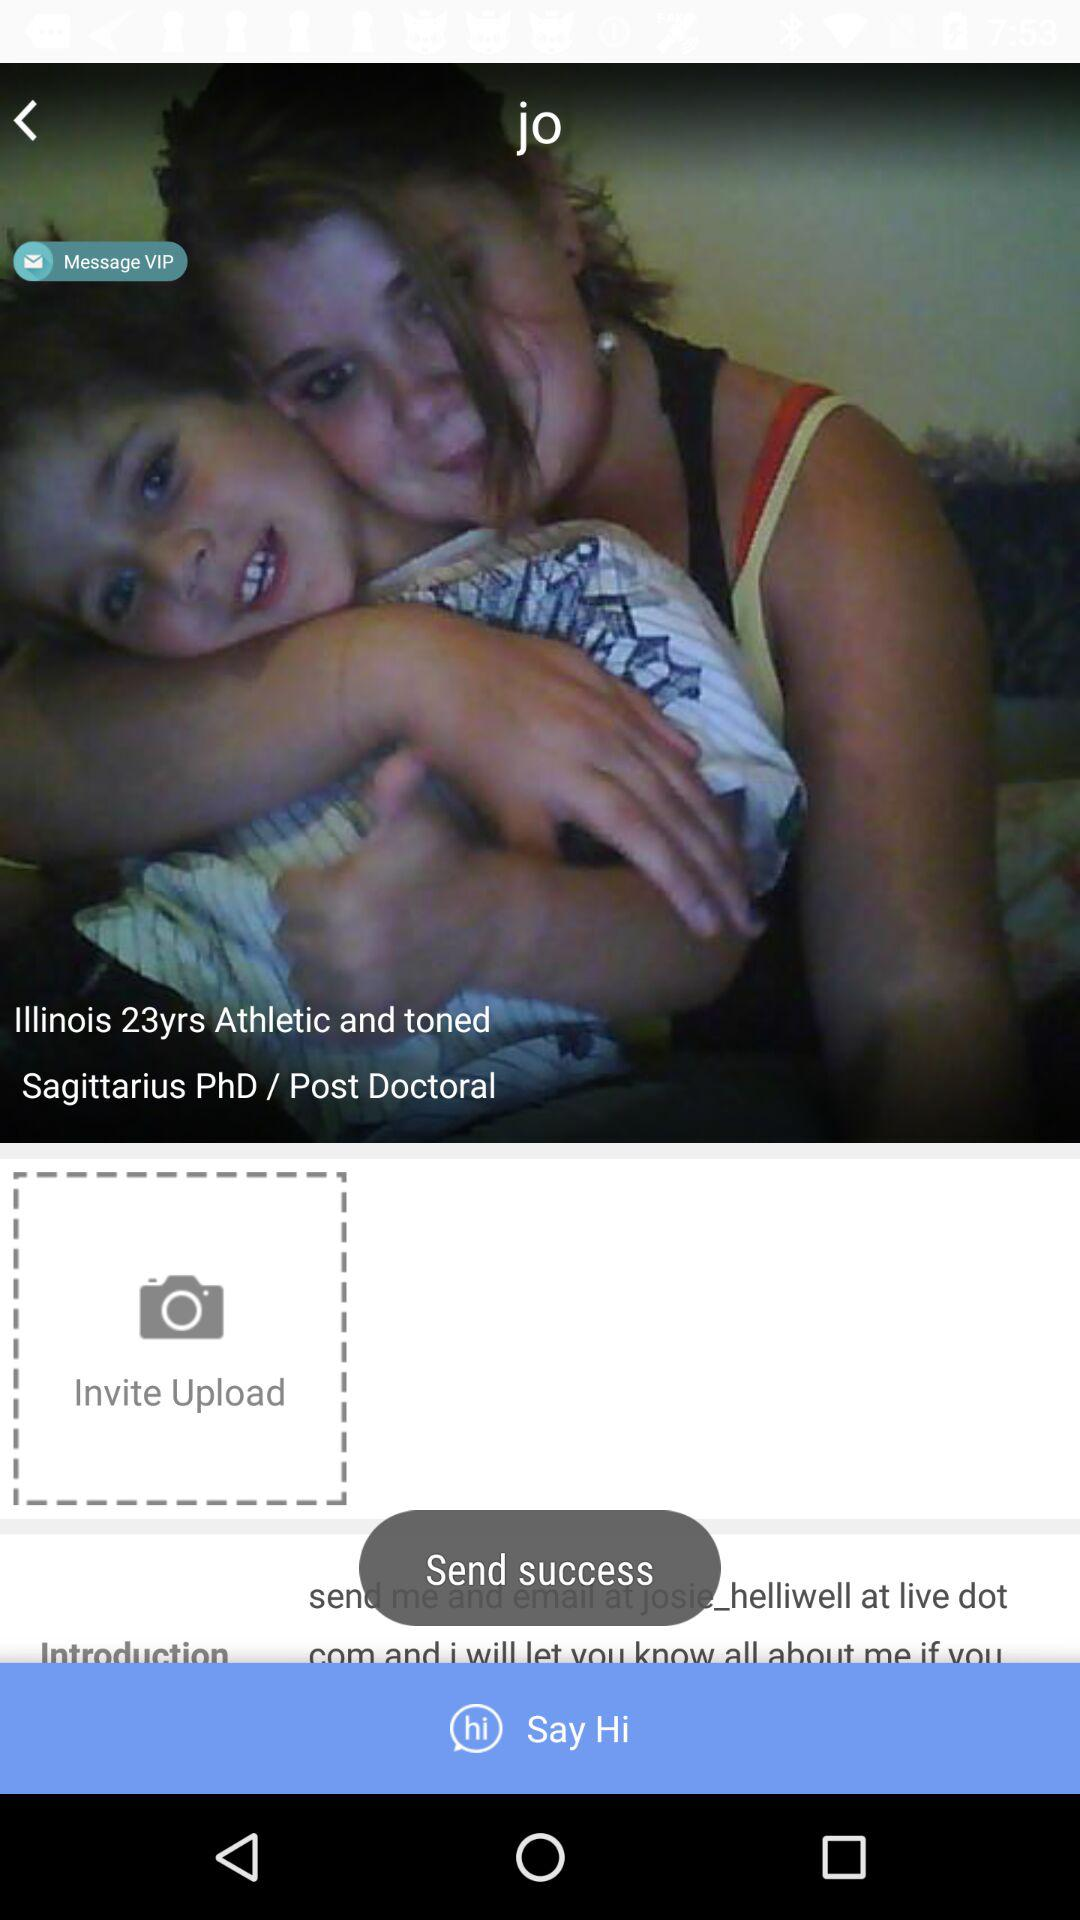What is the qualification of the user? The qualification of the user is PhD/post doctoral. 